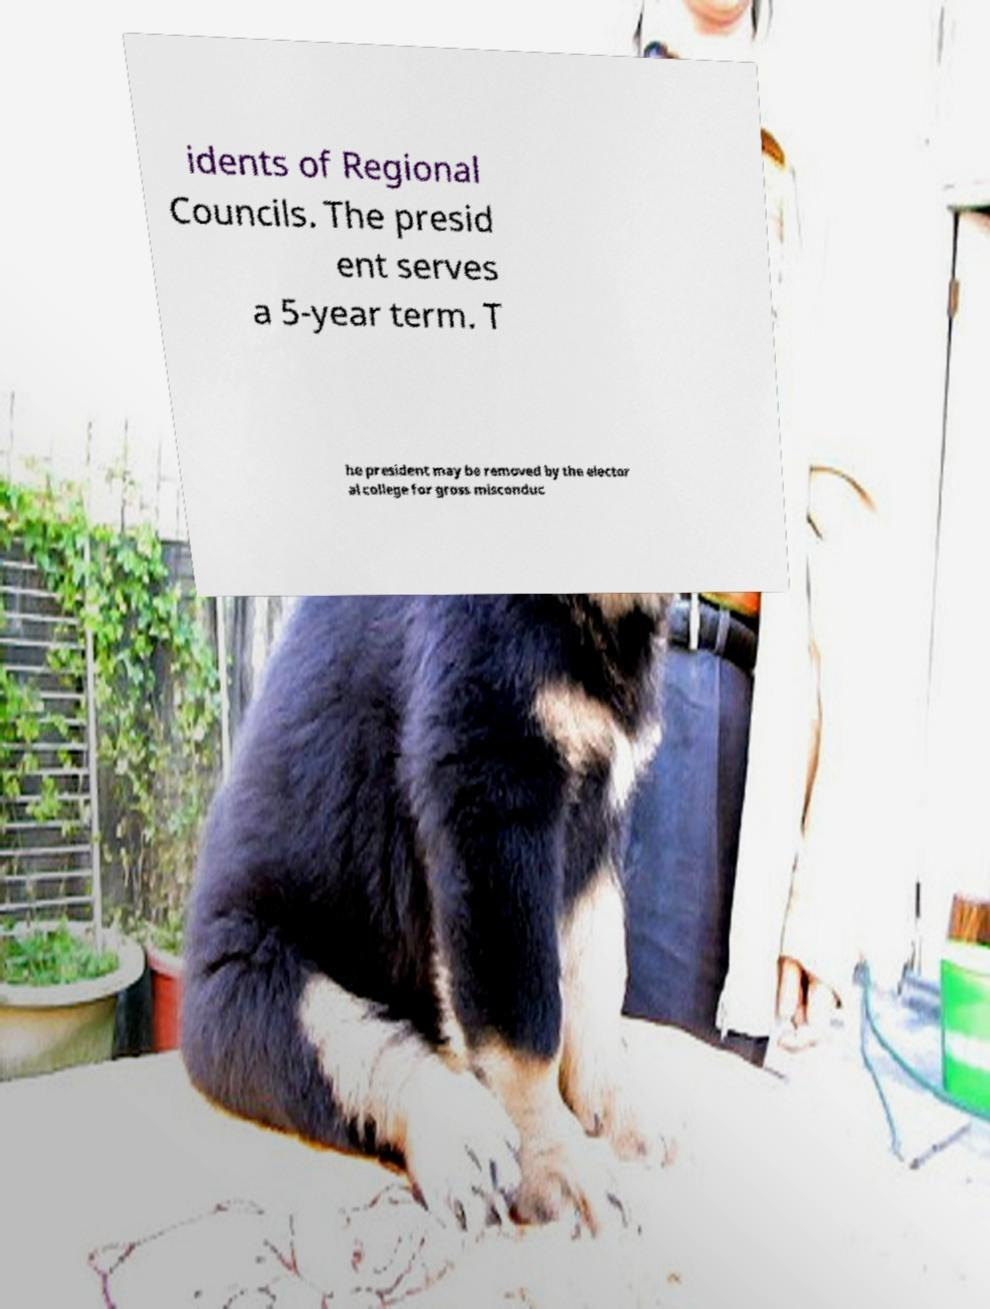For documentation purposes, I need the text within this image transcribed. Could you provide that? idents of Regional Councils. The presid ent serves a 5-year term. T he president may be removed by the elector al college for gross misconduc 